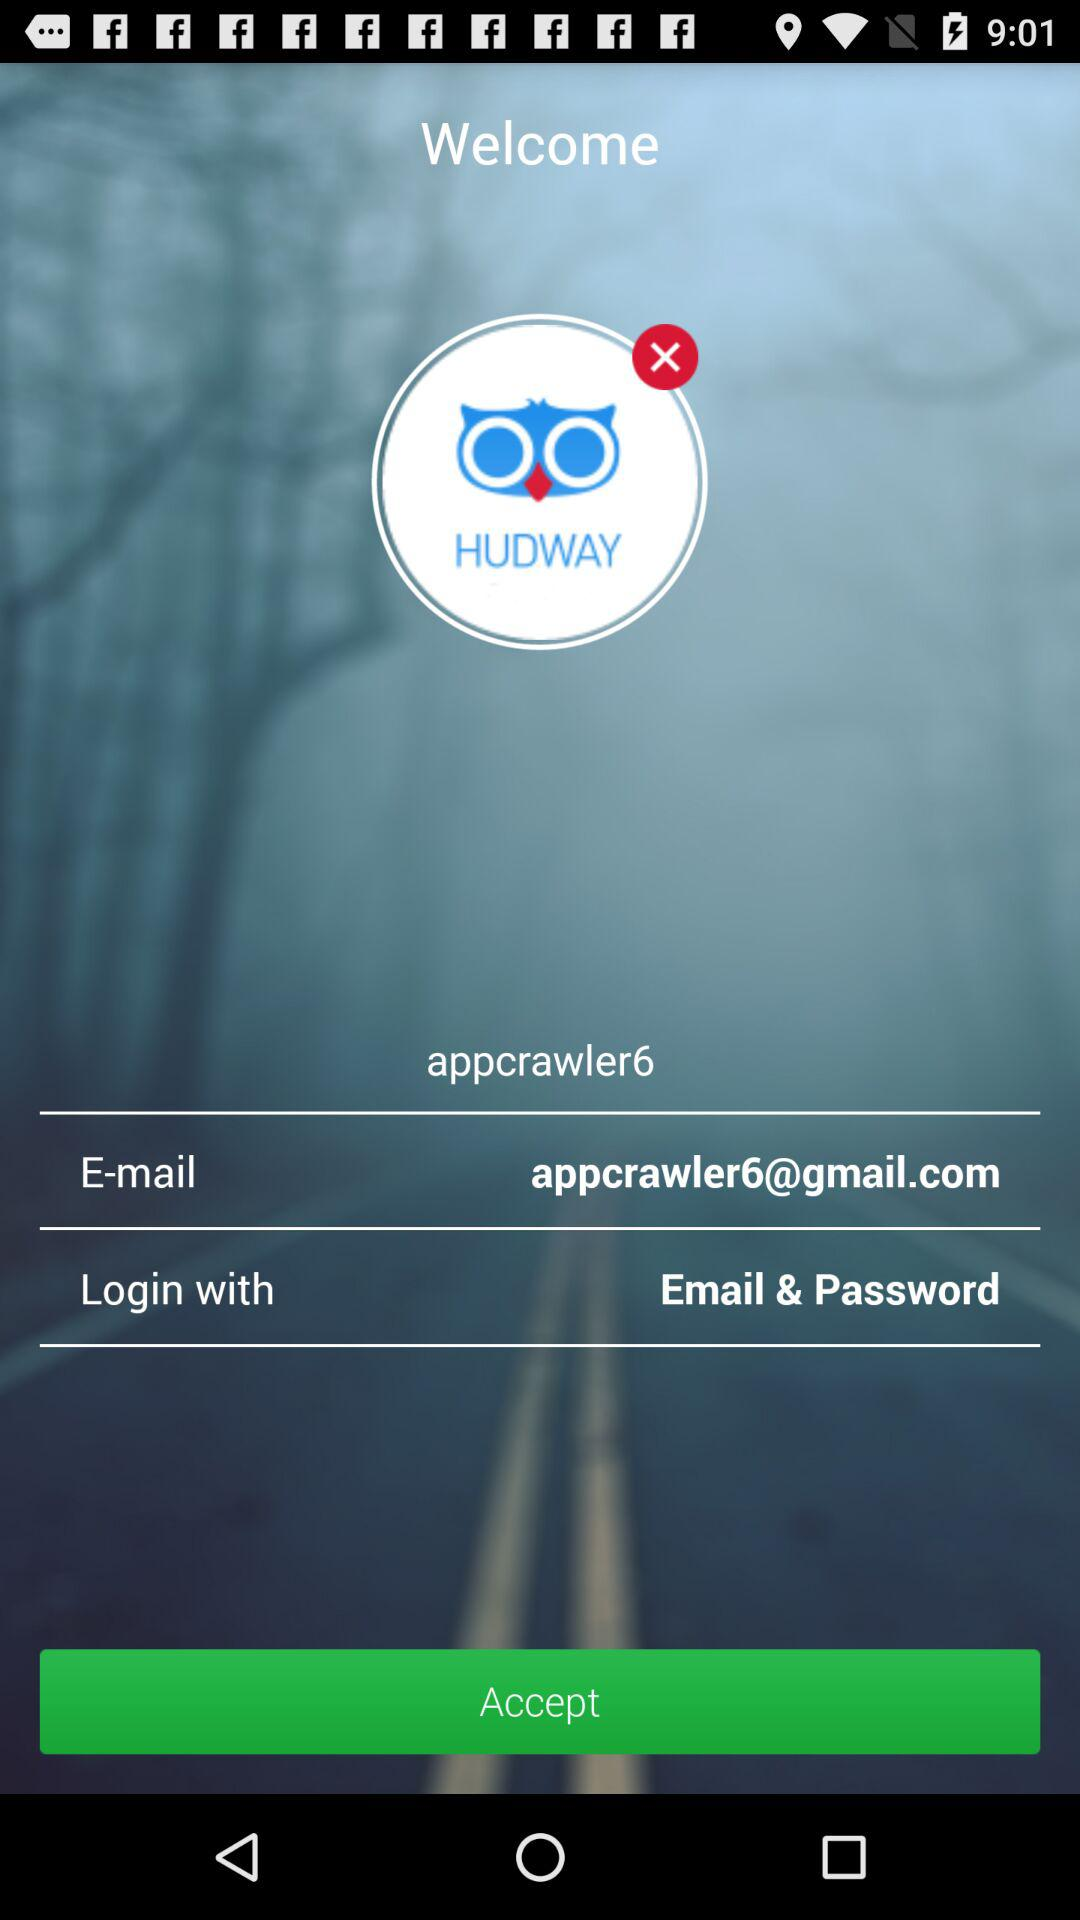How many text inputs are on the screen?
Answer the question using a single word or phrase. 3 